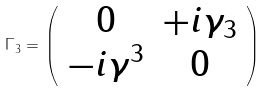Convert formula to latex. <formula><loc_0><loc_0><loc_500><loc_500>\Gamma _ { 3 } = \left ( \begin{array} { c c } 0 & + i \gamma _ { 3 } \\ - i \gamma ^ { 3 } & 0 \end{array} \right )</formula> 